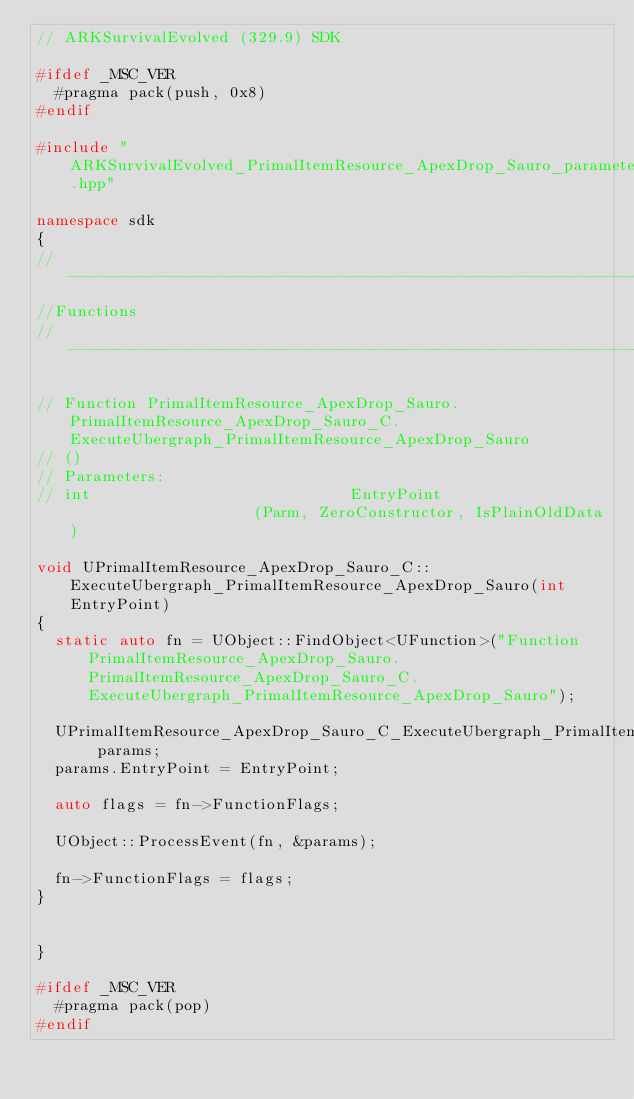Convert code to text. <code><loc_0><loc_0><loc_500><loc_500><_C++_>// ARKSurvivalEvolved (329.9) SDK

#ifdef _MSC_VER
	#pragma pack(push, 0x8)
#endif

#include "ARKSurvivalEvolved_PrimalItemResource_ApexDrop_Sauro_parameters.hpp"

namespace sdk
{
//---------------------------------------------------------------------------
//Functions
//---------------------------------------------------------------------------

// Function PrimalItemResource_ApexDrop_Sauro.PrimalItemResource_ApexDrop_Sauro_C.ExecuteUbergraph_PrimalItemResource_ApexDrop_Sauro
// ()
// Parameters:
// int                            EntryPoint                     (Parm, ZeroConstructor, IsPlainOldData)

void UPrimalItemResource_ApexDrop_Sauro_C::ExecuteUbergraph_PrimalItemResource_ApexDrop_Sauro(int EntryPoint)
{
	static auto fn = UObject::FindObject<UFunction>("Function PrimalItemResource_ApexDrop_Sauro.PrimalItemResource_ApexDrop_Sauro_C.ExecuteUbergraph_PrimalItemResource_ApexDrop_Sauro");

	UPrimalItemResource_ApexDrop_Sauro_C_ExecuteUbergraph_PrimalItemResource_ApexDrop_Sauro_Params params;
	params.EntryPoint = EntryPoint;

	auto flags = fn->FunctionFlags;

	UObject::ProcessEvent(fn, &params);

	fn->FunctionFlags = flags;
}


}

#ifdef _MSC_VER
	#pragma pack(pop)
#endif
</code> 